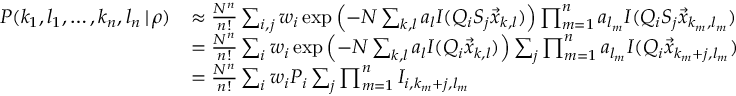Convert formula to latex. <formula><loc_0><loc_0><loc_500><loc_500>\begin{array} { r l } { P ( k _ { 1 } , l _ { 1 } , \dots , k _ { n } , l _ { n } \, | \, \rho ) } & { \approx \frac { N ^ { n } } { n ! } \sum _ { i , j } w _ { i } \exp \left ( - N \sum _ { k , l } a _ { l } I ( Q _ { i } S _ { j } \vec { x } _ { k , l } ) \right ) \prod _ { m = 1 } ^ { n } a _ { l _ { m } } I ( Q _ { i } S _ { j } \vec { x } _ { k _ { m } , l _ { m } } ) } \\ & { = \frac { N ^ { n } } { n ! } \sum _ { i } w _ { i } \exp \left ( - N \sum _ { k , l } a _ { l } I ( Q _ { i } \vec { x } _ { k , l } ) \right ) \sum _ { j } \prod _ { m = 1 } ^ { n } a _ { l _ { m } } I ( Q _ { i } \vec { x } _ { k _ { m } + j , l _ { m } } ) } \\ & { = \frac { N ^ { n } } { n ! } \sum _ { i } w _ { i } P _ { i } \sum _ { j } \prod _ { m = 1 } ^ { n } I _ { i , k _ { m } + j , l _ { m } } } \end{array}</formula> 